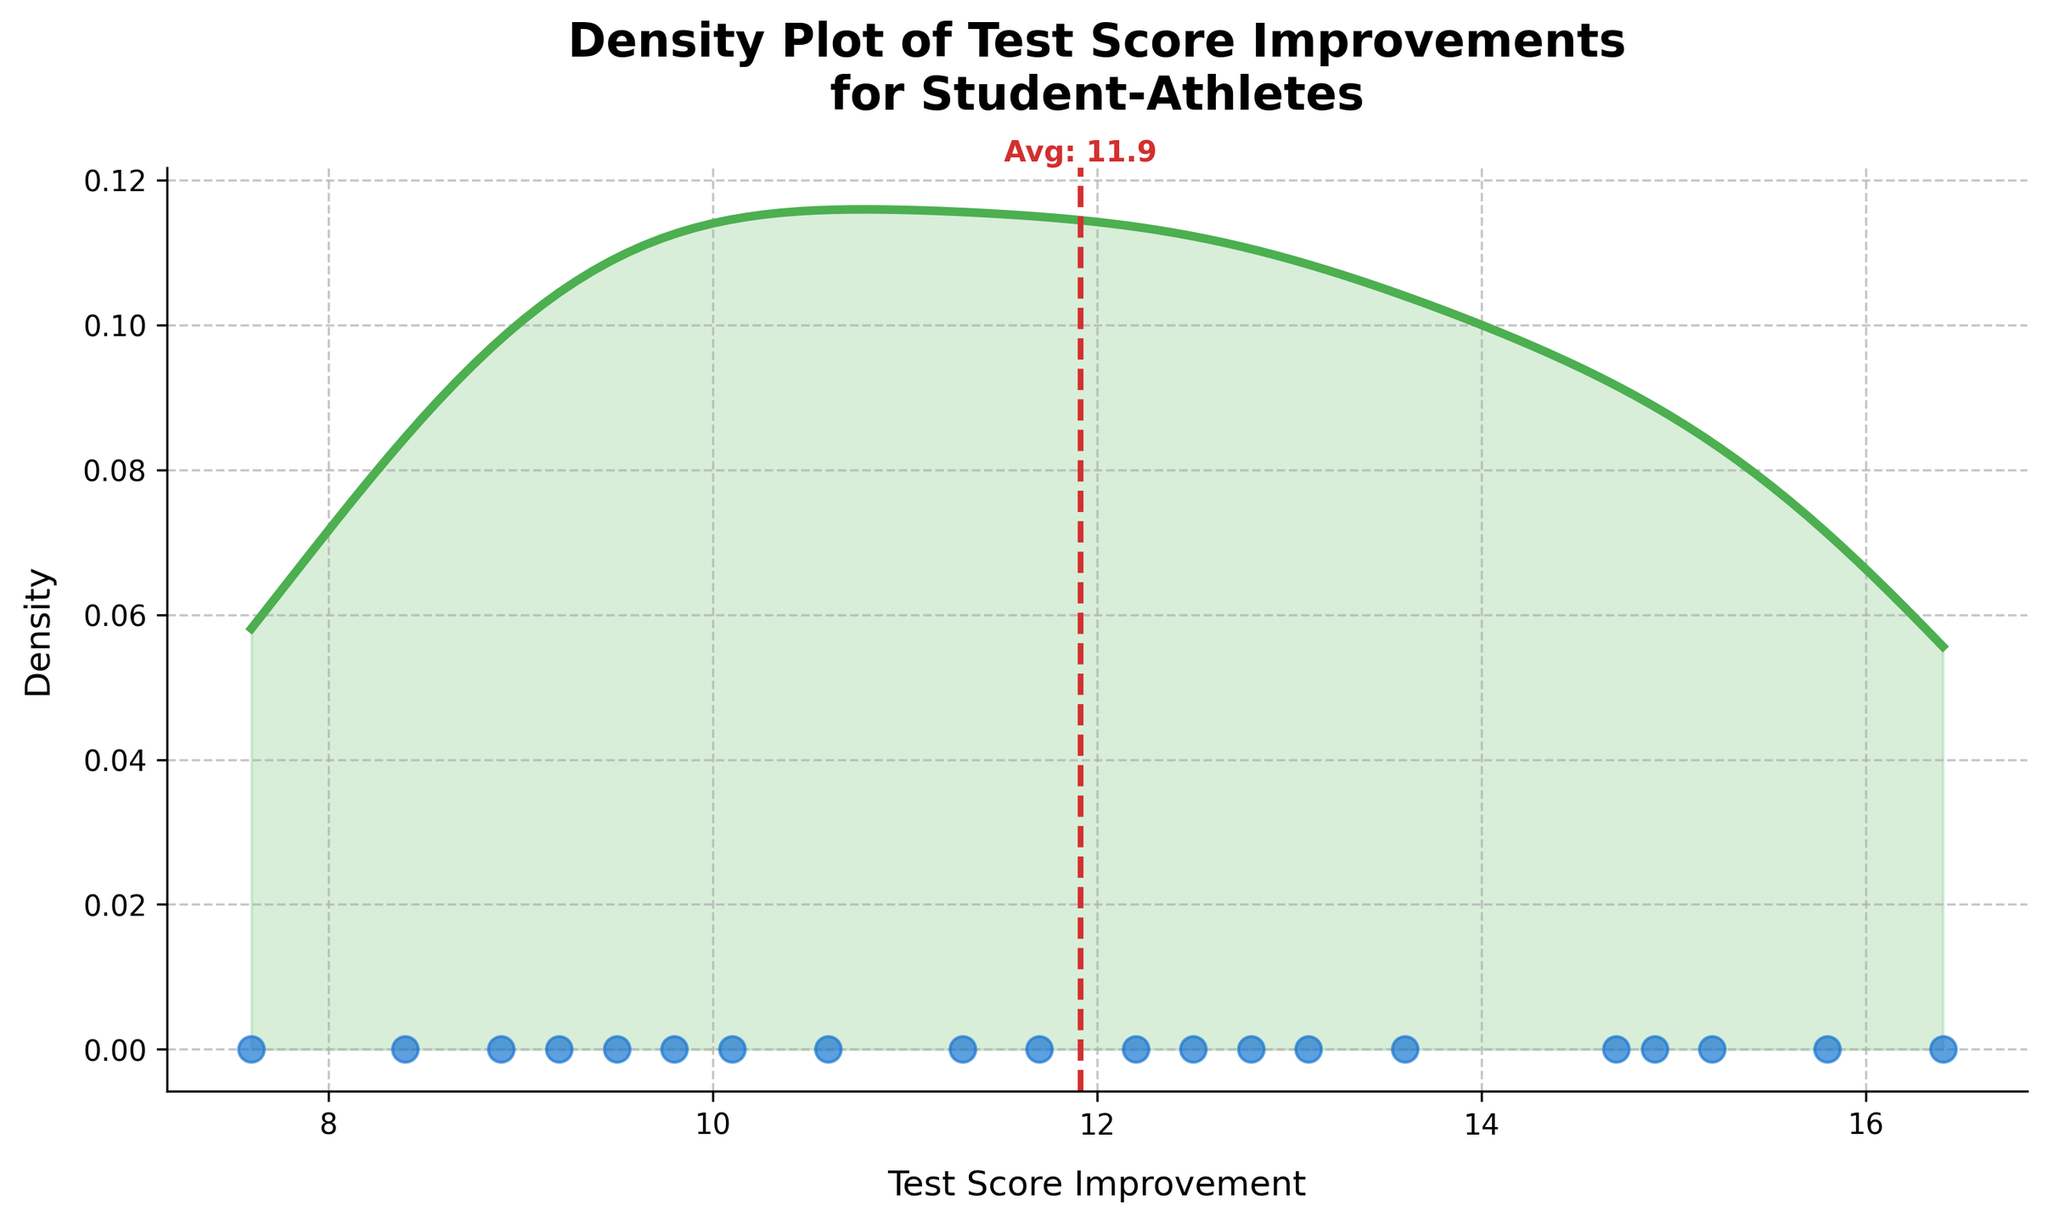What is the title of the plot? The title is displayed at the top of the plot. Reading it provides the direct answer.
Answer: Density Plot of Test Score Improvements for Student-Athletes What is the x-axis representing in this plot? The x-axis label below the axis shows what the x-axis is representing.
Answer: Test Score Improvement What color is used for the density line in the plot? The color of the density line can be distinguished visually.
Answer: Green How many student-athletes' test score improvements are shown in the scatter plot? Count the number of blue dots in the scatter plot to find the answer.
Answer: 20 What is the mean test score improvement? The red vertical dashed line indicates the mean value, and the corresponding label shows its numerical value.
Answer: 12.2 Which student has scored the highest improvement? Among the blue scatter points, identify the rightmost one and refer to the hover label for the corresponding highest value.
Answer: Rashad Wilson What is the approximate density value at a test score improvement of 15? Find the density value corresponding to 15 on the x-axis by looking at the height of the green density curve at that point.
Answer: Around 0.05 Is the test score improvement distribution symmetric? Observing how the density curve shapes around the mean will reveal if it appears symmetric or not.
Answer: No Which two students have the closest test score improvements? Examine data points in the scatter plot and identify the two blue dots closest horizontally, then cross-reference them with the data labels.
Answer: Jermaine Foster and Michael Johnson How does the test score improvement for Dwayne Williams compare to the mean test score improvement? Locate the scatter plot point for Dwayne Williams and compare its position relative to the red dashed mean line.
Answer: Higher 